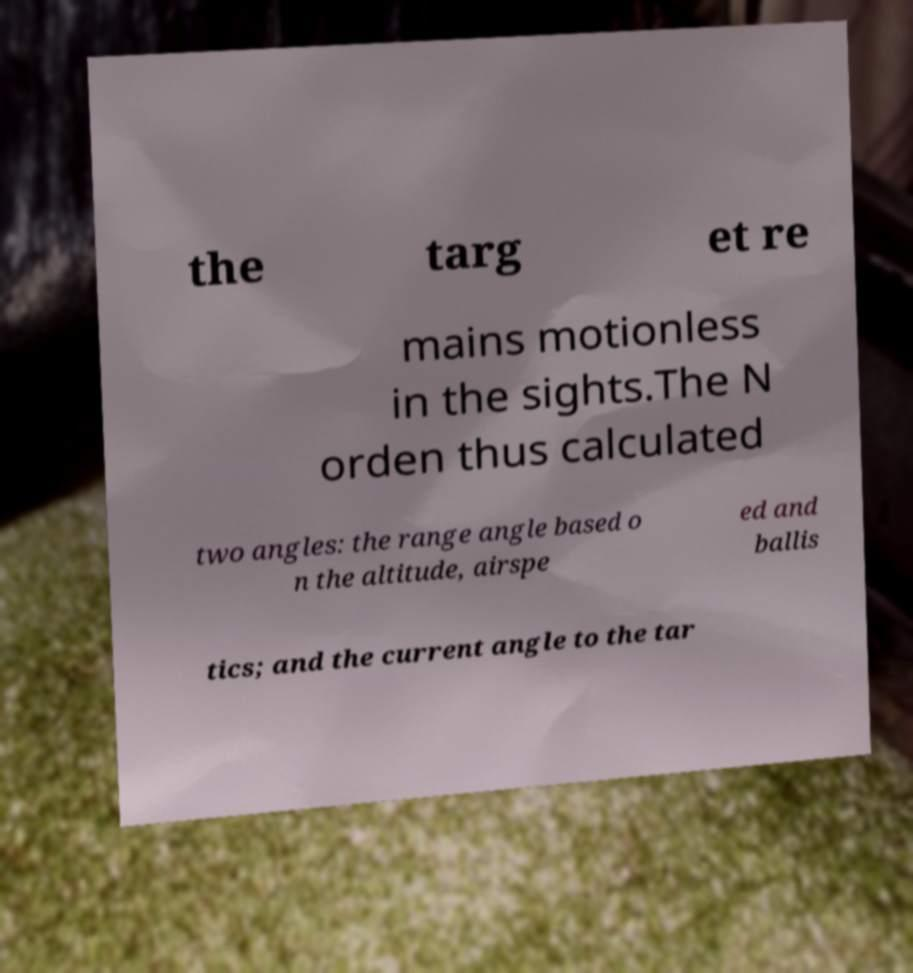Please read and relay the text visible in this image. What does it say? the targ et re mains motionless in the sights.The N orden thus calculated two angles: the range angle based o n the altitude, airspe ed and ballis tics; and the current angle to the tar 